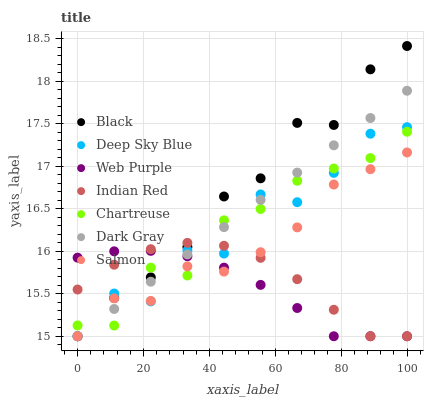Does Web Purple have the minimum area under the curve?
Answer yes or no. Yes. Does Black have the maximum area under the curve?
Answer yes or no. Yes. Does Salmon have the minimum area under the curve?
Answer yes or no. No. Does Salmon have the maximum area under the curve?
Answer yes or no. No. Is Dark Gray the smoothest?
Answer yes or no. Yes. Is Deep Sky Blue the roughest?
Answer yes or no. Yes. Is Salmon the smoothest?
Answer yes or no. No. Is Salmon the roughest?
Answer yes or no. No. Does Deep Sky Blue have the lowest value?
Answer yes or no. Yes. Does Chartreuse have the lowest value?
Answer yes or no. No. Does Black have the highest value?
Answer yes or no. Yes. Does Salmon have the highest value?
Answer yes or no. No. Does Dark Gray intersect Salmon?
Answer yes or no. Yes. Is Dark Gray less than Salmon?
Answer yes or no. No. Is Dark Gray greater than Salmon?
Answer yes or no. No. 